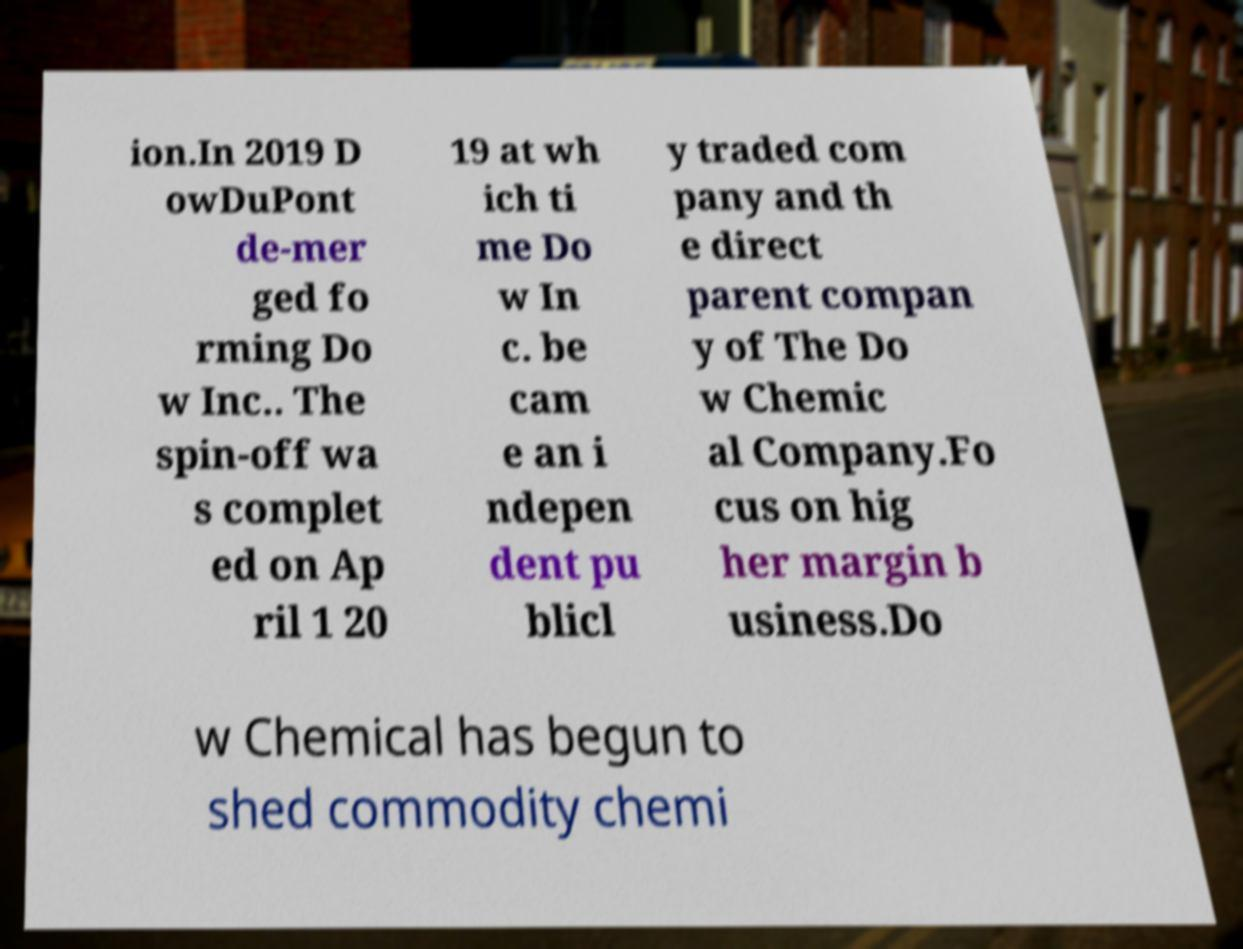Please read and relay the text visible in this image. What does it say? ion.In 2019 D owDuPont de-mer ged fo rming Do w Inc.. The spin-off wa s complet ed on Ap ril 1 20 19 at wh ich ti me Do w In c. be cam e an i ndepen dent pu blicl y traded com pany and th e direct parent compan y of The Do w Chemic al Company.Fo cus on hig her margin b usiness.Do w Chemical has begun to shed commodity chemi 